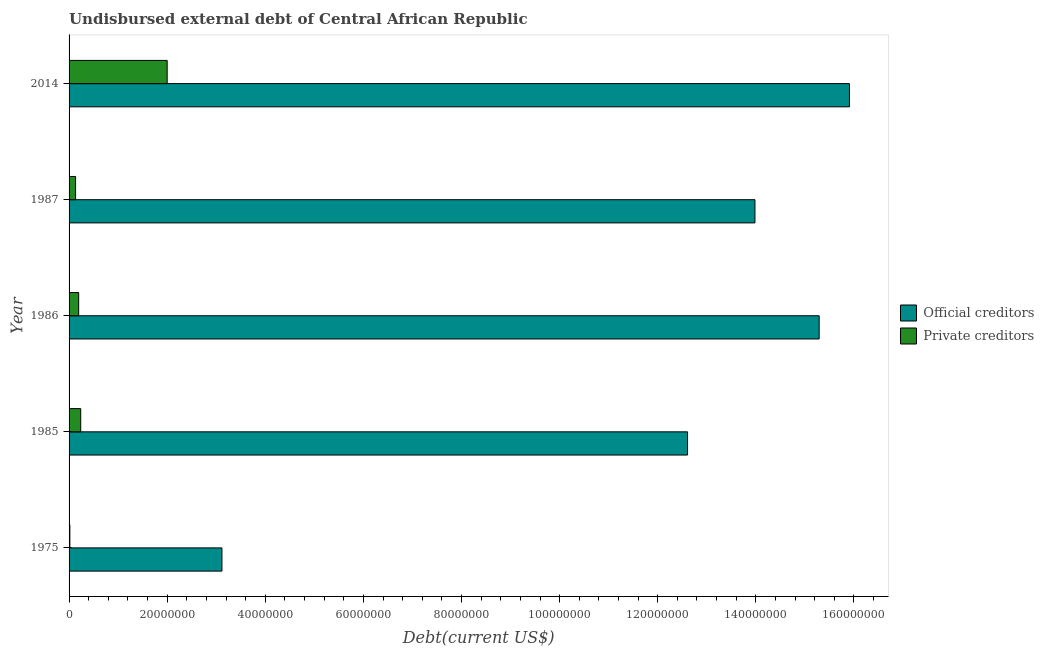How many different coloured bars are there?
Your answer should be compact. 2. How many groups of bars are there?
Make the answer very short. 5. Are the number of bars per tick equal to the number of legend labels?
Your answer should be compact. Yes. What is the label of the 1st group of bars from the top?
Keep it short and to the point. 2014. In how many cases, is the number of bars for a given year not equal to the number of legend labels?
Give a very brief answer. 0. What is the undisbursed external debt of private creditors in 1987?
Keep it short and to the point. 1.33e+06. Across all years, what is the maximum undisbursed external debt of private creditors?
Ensure brevity in your answer.  2.00e+07. Across all years, what is the minimum undisbursed external debt of private creditors?
Offer a terse response. 1.62e+05. In which year was the undisbursed external debt of private creditors minimum?
Offer a very short reply. 1975. What is the total undisbursed external debt of private creditors in the graph?
Provide a succinct answer. 2.58e+07. What is the difference between the undisbursed external debt of private creditors in 1975 and that in 2014?
Ensure brevity in your answer.  -1.98e+07. What is the difference between the undisbursed external debt of private creditors in 1986 and the undisbursed external debt of official creditors in 2014?
Give a very brief answer. -1.57e+08. What is the average undisbursed external debt of official creditors per year?
Make the answer very short. 1.22e+08. In the year 1975, what is the difference between the undisbursed external debt of official creditors and undisbursed external debt of private creditors?
Keep it short and to the point. 3.10e+07. What is the ratio of the undisbursed external debt of private creditors in 1986 to that in 1987?
Offer a very short reply. 1.47. Is the difference between the undisbursed external debt of official creditors in 1975 and 1986 greater than the difference between the undisbursed external debt of private creditors in 1975 and 1986?
Offer a terse response. No. What is the difference between the highest and the second highest undisbursed external debt of private creditors?
Offer a terse response. 1.76e+07. What is the difference between the highest and the lowest undisbursed external debt of official creditors?
Your answer should be very brief. 1.28e+08. In how many years, is the undisbursed external debt of official creditors greater than the average undisbursed external debt of official creditors taken over all years?
Your response must be concise. 4. Is the sum of the undisbursed external debt of private creditors in 1987 and 2014 greater than the maximum undisbursed external debt of official creditors across all years?
Ensure brevity in your answer.  No. What does the 2nd bar from the top in 1975 represents?
Give a very brief answer. Official creditors. What does the 1st bar from the bottom in 1975 represents?
Your answer should be compact. Official creditors. How many years are there in the graph?
Make the answer very short. 5. Are the values on the major ticks of X-axis written in scientific E-notation?
Provide a short and direct response. No. Does the graph contain any zero values?
Your answer should be compact. No. How are the legend labels stacked?
Provide a short and direct response. Vertical. What is the title of the graph?
Your answer should be compact. Undisbursed external debt of Central African Republic. What is the label or title of the X-axis?
Your response must be concise. Debt(current US$). What is the label or title of the Y-axis?
Your answer should be compact. Year. What is the Debt(current US$) of Official creditors in 1975?
Provide a succinct answer. 3.12e+07. What is the Debt(current US$) in Private creditors in 1975?
Offer a terse response. 1.62e+05. What is the Debt(current US$) in Official creditors in 1985?
Give a very brief answer. 1.26e+08. What is the Debt(current US$) of Private creditors in 1985?
Make the answer very short. 2.37e+06. What is the Debt(current US$) in Official creditors in 1986?
Your answer should be very brief. 1.53e+08. What is the Debt(current US$) of Private creditors in 1986?
Provide a succinct answer. 1.96e+06. What is the Debt(current US$) of Official creditors in 1987?
Your answer should be compact. 1.40e+08. What is the Debt(current US$) in Private creditors in 1987?
Ensure brevity in your answer.  1.33e+06. What is the Debt(current US$) of Official creditors in 2014?
Your answer should be very brief. 1.59e+08. Across all years, what is the maximum Debt(current US$) of Official creditors?
Your response must be concise. 1.59e+08. Across all years, what is the minimum Debt(current US$) of Official creditors?
Ensure brevity in your answer.  3.12e+07. Across all years, what is the minimum Debt(current US$) in Private creditors?
Your response must be concise. 1.62e+05. What is the total Debt(current US$) of Official creditors in the graph?
Provide a short and direct response. 6.09e+08. What is the total Debt(current US$) in Private creditors in the graph?
Your answer should be very brief. 2.58e+07. What is the difference between the Debt(current US$) of Official creditors in 1975 and that in 1985?
Provide a succinct answer. -9.49e+07. What is the difference between the Debt(current US$) in Private creditors in 1975 and that in 1985?
Keep it short and to the point. -2.21e+06. What is the difference between the Debt(current US$) in Official creditors in 1975 and that in 1986?
Your response must be concise. -1.22e+08. What is the difference between the Debt(current US$) of Private creditors in 1975 and that in 1986?
Your answer should be very brief. -1.79e+06. What is the difference between the Debt(current US$) in Official creditors in 1975 and that in 1987?
Provide a short and direct response. -1.09e+08. What is the difference between the Debt(current US$) in Private creditors in 1975 and that in 1987?
Make the answer very short. -1.17e+06. What is the difference between the Debt(current US$) of Official creditors in 1975 and that in 2014?
Your answer should be very brief. -1.28e+08. What is the difference between the Debt(current US$) of Private creditors in 1975 and that in 2014?
Your answer should be compact. -1.98e+07. What is the difference between the Debt(current US$) in Official creditors in 1985 and that in 1986?
Your answer should be very brief. -2.68e+07. What is the difference between the Debt(current US$) in Private creditors in 1985 and that in 1986?
Ensure brevity in your answer.  4.17e+05. What is the difference between the Debt(current US$) in Official creditors in 1985 and that in 1987?
Keep it short and to the point. -1.37e+07. What is the difference between the Debt(current US$) of Private creditors in 1985 and that in 1987?
Offer a very short reply. 1.04e+06. What is the difference between the Debt(current US$) of Official creditors in 1985 and that in 2014?
Your response must be concise. -3.30e+07. What is the difference between the Debt(current US$) of Private creditors in 1985 and that in 2014?
Your answer should be very brief. -1.76e+07. What is the difference between the Debt(current US$) in Official creditors in 1986 and that in 1987?
Offer a terse response. 1.31e+07. What is the difference between the Debt(current US$) of Private creditors in 1986 and that in 1987?
Ensure brevity in your answer.  6.28e+05. What is the difference between the Debt(current US$) of Official creditors in 1986 and that in 2014?
Your response must be concise. -6.18e+06. What is the difference between the Debt(current US$) in Private creditors in 1986 and that in 2014?
Your answer should be compact. -1.80e+07. What is the difference between the Debt(current US$) of Official creditors in 1987 and that in 2014?
Your answer should be very brief. -1.93e+07. What is the difference between the Debt(current US$) in Private creditors in 1987 and that in 2014?
Provide a short and direct response. -1.87e+07. What is the difference between the Debt(current US$) in Official creditors in 1975 and the Debt(current US$) in Private creditors in 1985?
Keep it short and to the point. 2.88e+07. What is the difference between the Debt(current US$) in Official creditors in 1975 and the Debt(current US$) in Private creditors in 1986?
Offer a very short reply. 2.92e+07. What is the difference between the Debt(current US$) of Official creditors in 1975 and the Debt(current US$) of Private creditors in 1987?
Ensure brevity in your answer.  2.98e+07. What is the difference between the Debt(current US$) of Official creditors in 1975 and the Debt(current US$) of Private creditors in 2014?
Your answer should be compact. 1.12e+07. What is the difference between the Debt(current US$) of Official creditors in 1985 and the Debt(current US$) of Private creditors in 1986?
Provide a short and direct response. 1.24e+08. What is the difference between the Debt(current US$) of Official creditors in 1985 and the Debt(current US$) of Private creditors in 1987?
Keep it short and to the point. 1.25e+08. What is the difference between the Debt(current US$) of Official creditors in 1985 and the Debt(current US$) of Private creditors in 2014?
Keep it short and to the point. 1.06e+08. What is the difference between the Debt(current US$) in Official creditors in 1986 and the Debt(current US$) in Private creditors in 1987?
Your answer should be compact. 1.52e+08. What is the difference between the Debt(current US$) of Official creditors in 1986 and the Debt(current US$) of Private creditors in 2014?
Provide a succinct answer. 1.33e+08. What is the difference between the Debt(current US$) of Official creditors in 1987 and the Debt(current US$) of Private creditors in 2014?
Offer a very short reply. 1.20e+08. What is the average Debt(current US$) in Official creditors per year?
Offer a terse response. 1.22e+08. What is the average Debt(current US$) in Private creditors per year?
Offer a very short reply. 5.16e+06. In the year 1975, what is the difference between the Debt(current US$) of Official creditors and Debt(current US$) of Private creditors?
Make the answer very short. 3.10e+07. In the year 1985, what is the difference between the Debt(current US$) of Official creditors and Debt(current US$) of Private creditors?
Provide a succinct answer. 1.24e+08. In the year 1986, what is the difference between the Debt(current US$) in Official creditors and Debt(current US$) in Private creditors?
Provide a short and direct response. 1.51e+08. In the year 1987, what is the difference between the Debt(current US$) in Official creditors and Debt(current US$) in Private creditors?
Your response must be concise. 1.38e+08. In the year 2014, what is the difference between the Debt(current US$) of Official creditors and Debt(current US$) of Private creditors?
Offer a terse response. 1.39e+08. What is the ratio of the Debt(current US$) in Official creditors in 1975 to that in 1985?
Provide a succinct answer. 0.25. What is the ratio of the Debt(current US$) of Private creditors in 1975 to that in 1985?
Give a very brief answer. 0.07. What is the ratio of the Debt(current US$) in Official creditors in 1975 to that in 1986?
Offer a terse response. 0.2. What is the ratio of the Debt(current US$) in Private creditors in 1975 to that in 1986?
Your response must be concise. 0.08. What is the ratio of the Debt(current US$) of Official creditors in 1975 to that in 1987?
Provide a short and direct response. 0.22. What is the ratio of the Debt(current US$) in Private creditors in 1975 to that in 1987?
Your response must be concise. 0.12. What is the ratio of the Debt(current US$) in Official creditors in 1975 to that in 2014?
Your response must be concise. 0.2. What is the ratio of the Debt(current US$) in Private creditors in 1975 to that in 2014?
Make the answer very short. 0.01. What is the ratio of the Debt(current US$) of Official creditors in 1985 to that in 1986?
Your answer should be very brief. 0.82. What is the ratio of the Debt(current US$) of Private creditors in 1985 to that in 1986?
Offer a terse response. 1.21. What is the ratio of the Debt(current US$) in Official creditors in 1985 to that in 1987?
Your answer should be very brief. 0.9. What is the ratio of the Debt(current US$) of Private creditors in 1985 to that in 1987?
Provide a short and direct response. 1.79. What is the ratio of the Debt(current US$) of Official creditors in 1985 to that in 2014?
Give a very brief answer. 0.79. What is the ratio of the Debt(current US$) of Private creditors in 1985 to that in 2014?
Offer a terse response. 0.12. What is the ratio of the Debt(current US$) of Official creditors in 1986 to that in 1987?
Keep it short and to the point. 1.09. What is the ratio of the Debt(current US$) in Private creditors in 1986 to that in 1987?
Provide a succinct answer. 1.47. What is the ratio of the Debt(current US$) of Official creditors in 1986 to that in 2014?
Make the answer very short. 0.96. What is the ratio of the Debt(current US$) in Private creditors in 1986 to that in 2014?
Ensure brevity in your answer.  0.1. What is the ratio of the Debt(current US$) of Official creditors in 1987 to that in 2014?
Your response must be concise. 0.88. What is the ratio of the Debt(current US$) in Private creditors in 1987 to that in 2014?
Give a very brief answer. 0.07. What is the difference between the highest and the second highest Debt(current US$) in Official creditors?
Give a very brief answer. 6.18e+06. What is the difference between the highest and the second highest Debt(current US$) in Private creditors?
Your response must be concise. 1.76e+07. What is the difference between the highest and the lowest Debt(current US$) of Official creditors?
Your answer should be compact. 1.28e+08. What is the difference between the highest and the lowest Debt(current US$) in Private creditors?
Offer a very short reply. 1.98e+07. 